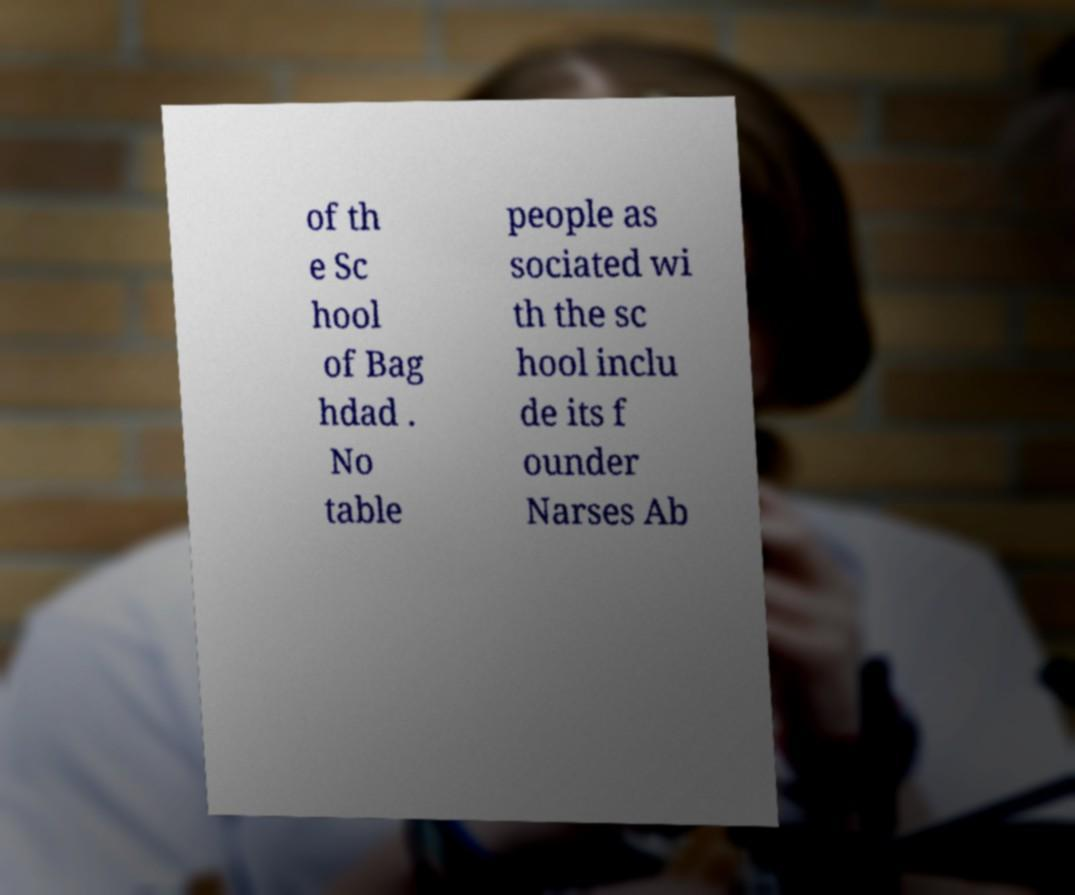Please read and relay the text visible in this image. What does it say? of th e Sc hool of Bag hdad . No table people as sociated wi th the sc hool inclu de its f ounder Narses Ab 